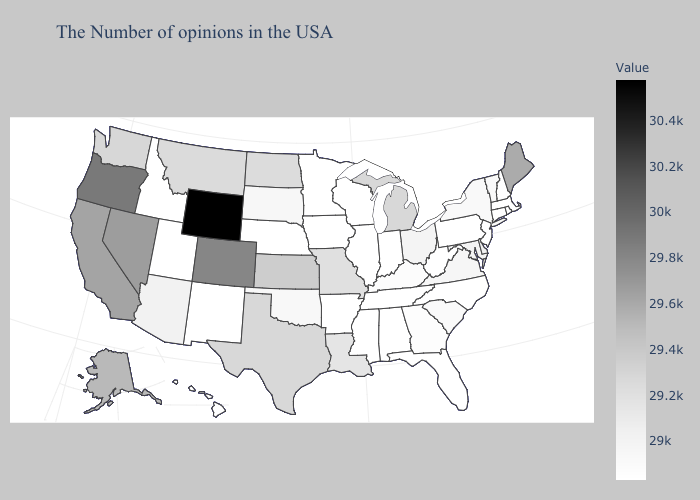Does the map have missing data?
Keep it brief. No. Does New Mexico have the highest value in the USA?
Give a very brief answer. No. Which states have the lowest value in the USA?
Write a very short answer. Massachusetts, Rhode Island, New Hampshire, Connecticut, New Jersey, Pennsylvania, North Carolina, West Virginia, Florida, Indiana, Alabama, Tennessee, Wisconsin, Illinois, Mississippi, Arkansas, Minnesota, Iowa, Nebraska, New Mexico, Utah, Idaho, Hawaii. Which states hav the highest value in the Northeast?
Write a very short answer. Maine. Which states have the lowest value in the USA?
Keep it brief. Massachusetts, Rhode Island, New Hampshire, Connecticut, New Jersey, Pennsylvania, North Carolina, West Virginia, Florida, Indiana, Alabama, Tennessee, Wisconsin, Illinois, Mississippi, Arkansas, Minnesota, Iowa, Nebraska, New Mexico, Utah, Idaho, Hawaii. Which states have the lowest value in the South?
Concise answer only. North Carolina, West Virginia, Florida, Alabama, Tennessee, Mississippi, Arkansas. 